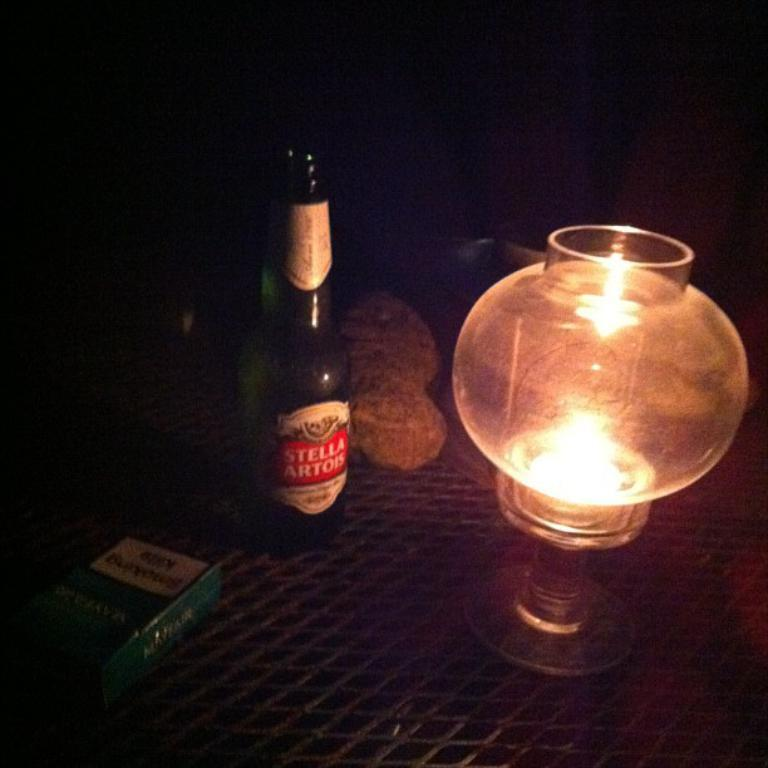<image>
Write a terse but informative summary of the picture. A bottle of Stella Artois beer is next to a candle and a pack of cigarettes. 